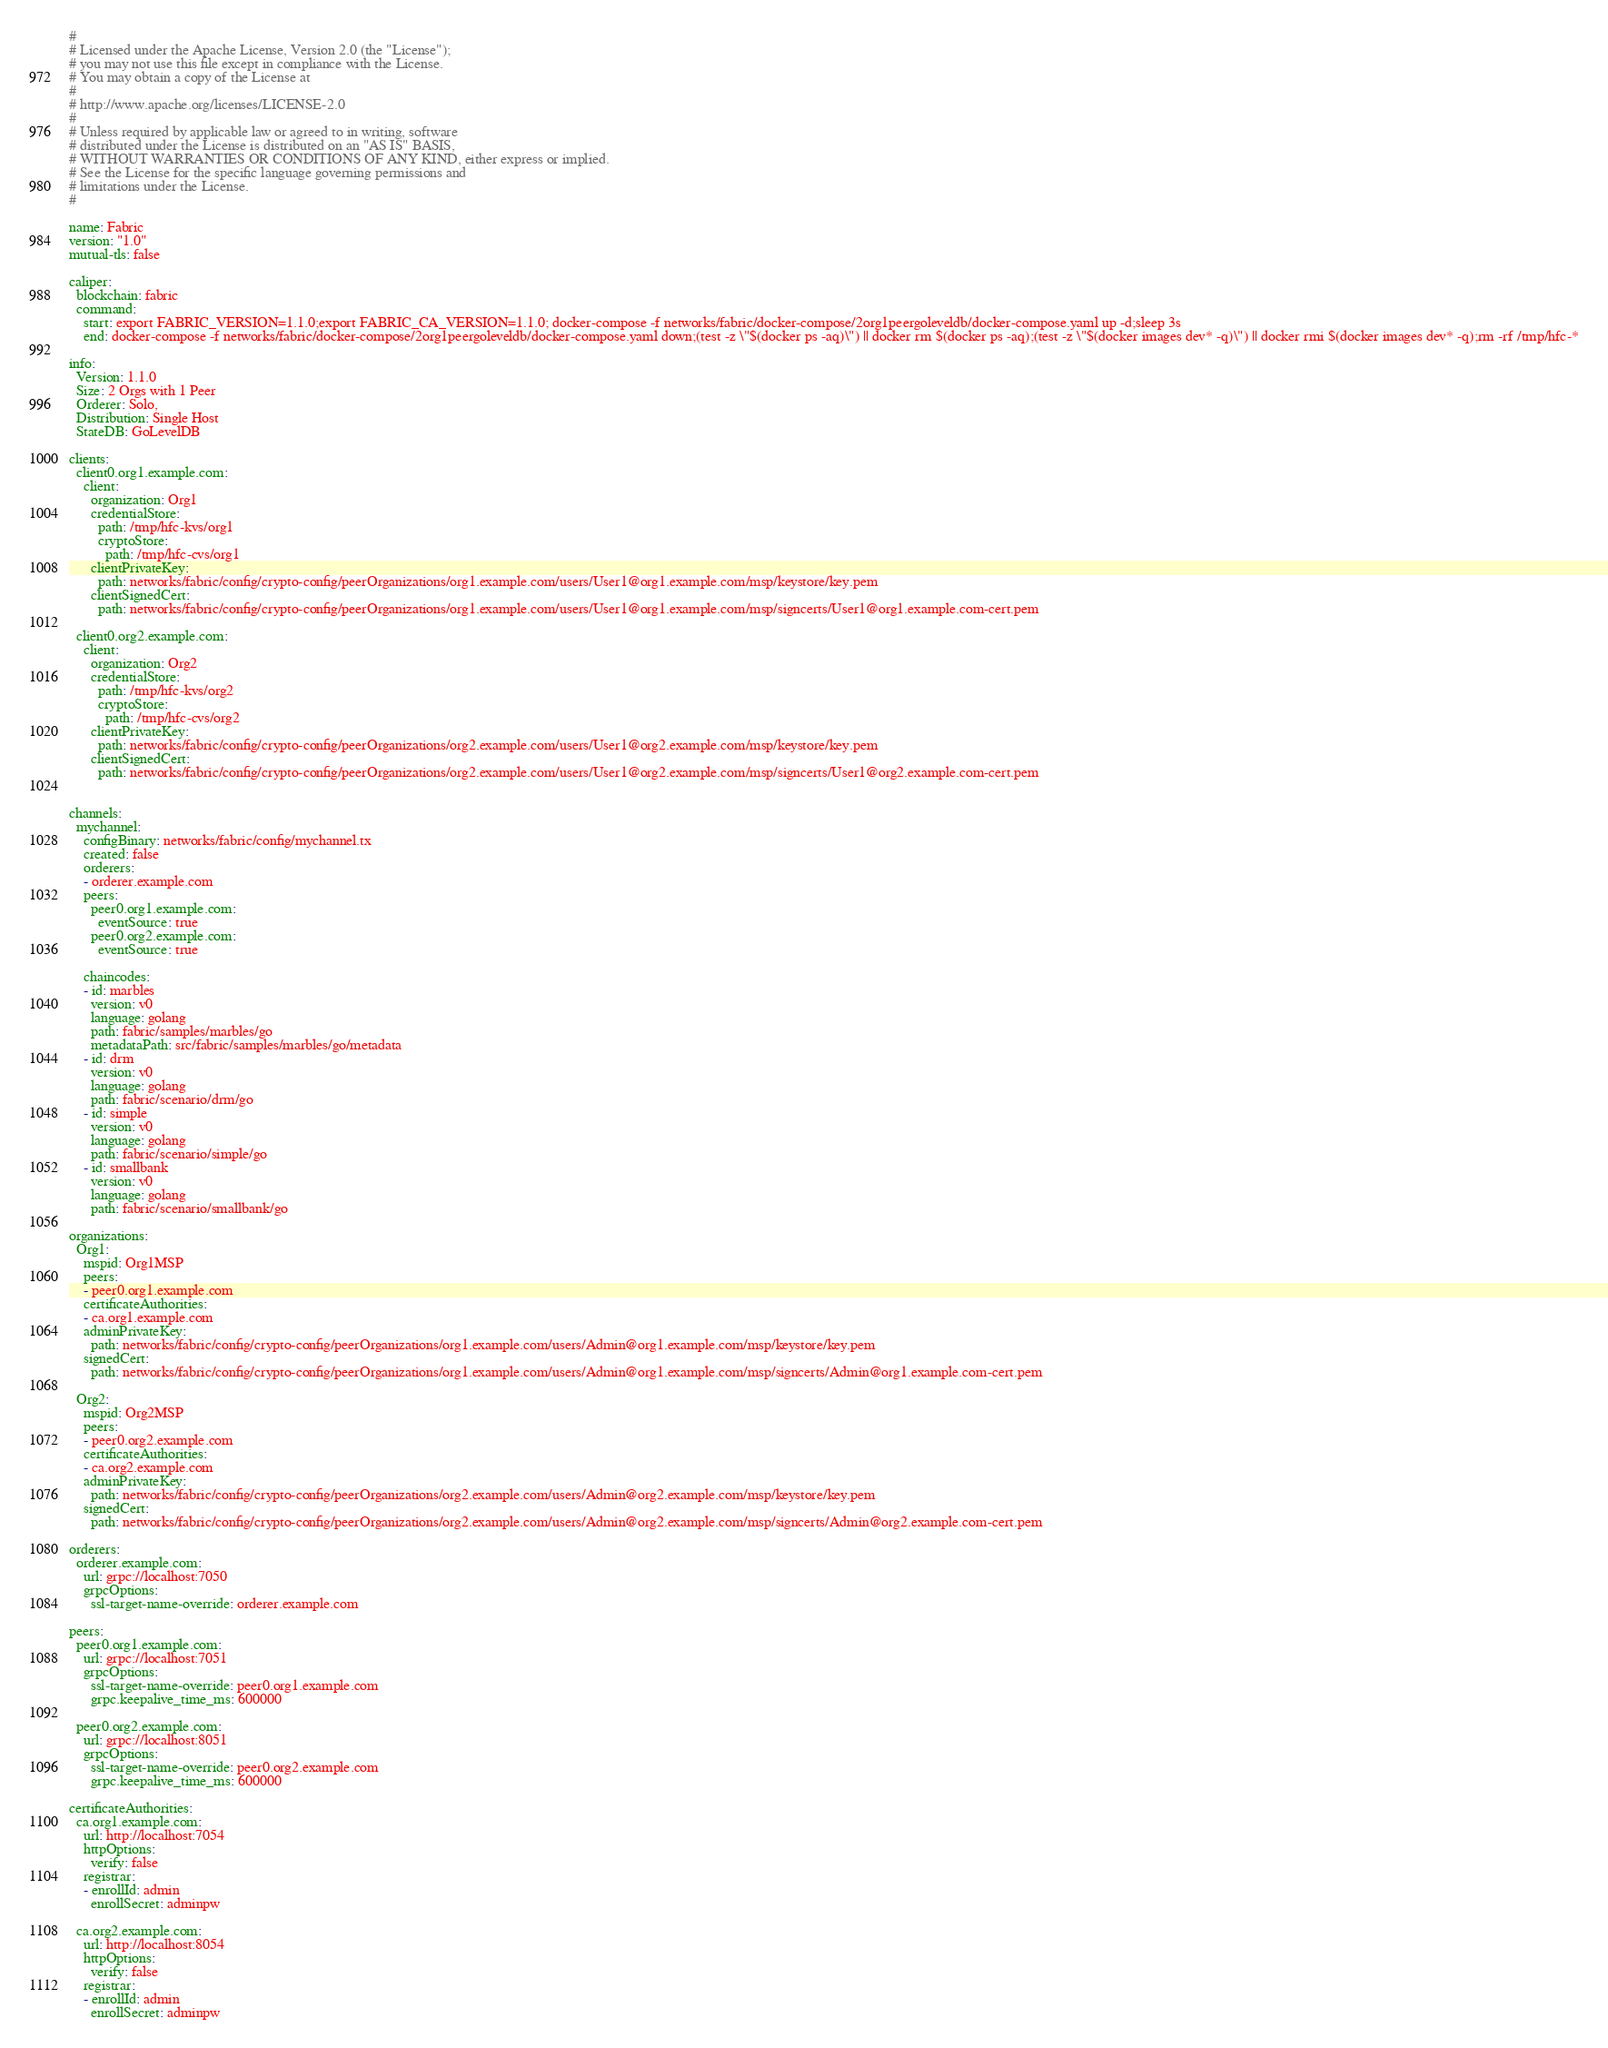<code> <loc_0><loc_0><loc_500><loc_500><_YAML_>#
# Licensed under the Apache License, Version 2.0 (the "License");
# you may not use this file except in compliance with the License.
# You may obtain a copy of the License at
#
# http://www.apache.org/licenses/LICENSE-2.0
#
# Unless required by applicable law or agreed to in writing, software
# distributed under the License is distributed on an "AS IS" BASIS,
# WITHOUT WARRANTIES OR CONDITIONS OF ANY KIND, either express or implied.
# See the License for the specific language governing permissions and
# limitations under the License.
# 

name: Fabric
version: "1.0"
mutual-tls: false

caliper:
  blockchain: fabric
  command:
    start: export FABRIC_VERSION=1.1.0;export FABRIC_CA_VERSION=1.1.0; docker-compose -f networks/fabric/docker-compose/2org1peergoleveldb/docker-compose.yaml up -d;sleep 3s
    end: docker-compose -f networks/fabric/docker-compose/2org1peergoleveldb/docker-compose.yaml down;(test -z \"$(docker ps -aq)\") || docker rm $(docker ps -aq);(test -z \"$(docker images dev* -q)\") || docker rmi $(docker images dev* -q);rm -rf /tmp/hfc-*

info:
  Version: 1.1.0
  Size: 2 Orgs with 1 Peer
  Orderer: Solo,
  Distribution: Single Host
  StateDB: GoLevelDB

clients:
  client0.org1.example.com:
    client:
      organization: Org1
      credentialStore:
        path: /tmp/hfc-kvs/org1
        cryptoStore:
          path: /tmp/hfc-cvs/org1
      clientPrivateKey:
        path: networks/fabric/config/crypto-config/peerOrganizations/org1.example.com/users/User1@org1.example.com/msp/keystore/key.pem
      clientSignedCert:
        path: networks/fabric/config/crypto-config/peerOrganizations/org1.example.com/users/User1@org1.example.com/msp/signcerts/User1@org1.example.com-cert.pem

  client0.org2.example.com:
    client:
      organization: Org2
      credentialStore:
        path: /tmp/hfc-kvs/org2
        cryptoStore:
          path: /tmp/hfc-cvs/org2
      clientPrivateKey:
        path: networks/fabric/config/crypto-config/peerOrganizations/org2.example.com/users/User1@org2.example.com/msp/keystore/key.pem
      clientSignedCert:
        path: networks/fabric/config/crypto-config/peerOrganizations/org2.example.com/users/User1@org2.example.com/msp/signcerts/User1@org2.example.com-cert.pem


channels:
  mychannel:
    configBinary: networks/fabric/config/mychannel.tx
    created: false
    orderers:
    - orderer.example.com
    peers:
      peer0.org1.example.com:
        eventSource: true
      peer0.org2.example.com:
        eventSource: true

    chaincodes:
    - id: marbles
      version: v0
      language: golang
      path: fabric/samples/marbles/go
      metadataPath: src/fabric/samples/marbles/go/metadata
    - id: drm
      version: v0
      language: golang
      path: fabric/scenario/drm/go
    - id: simple
      version: v0
      language: golang
      path: fabric/scenario/simple/go
    - id: smallbank
      version: v0
      language: golang
      path: fabric/scenario/smallbank/go

organizations:
  Org1:
    mspid: Org1MSP
    peers:
    - peer0.org1.example.com
    certificateAuthorities:
    - ca.org1.example.com
    adminPrivateKey:
      path: networks/fabric/config/crypto-config/peerOrganizations/org1.example.com/users/Admin@org1.example.com/msp/keystore/key.pem
    signedCert:
      path: networks/fabric/config/crypto-config/peerOrganizations/org1.example.com/users/Admin@org1.example.com/msp/signcerts/Admin@org1.example.com-cert.pem

  Org2:
    mspid: Org2MSP
    peers:
    - peer0.org2.example.com
    certificateAuthorities:
    - ca.org2.example.com
    adminPrivateKey:
      path: networks/fabric/config/crypto-config/peerOrganizations/org2.example.com/users/Admin@org2.example.com/msp/keystore/key.pem
    signedCert:
      path: networks/fabric/config/crypto-config/peerOrganizations/org2.example.com/users/Admin@org2.example.com/msp/signcerts/Admin@org2.example.com-cert.pem

orderers:
  orderer.example.com:
    url: grpc://localhost:7050
    grpcOptions:
      ssl-target-name-override: orderer.example.com

peers:
  peer0.org1.example.com:
    url: grpc://localhost:7051
    grpcOptions:
      ssl-target-name-override: peer0.org1.example.com
      grpc.keepalive_time_ms: 600000

  peer0.org2.example.com:
    url: grpc://localhost:8051
    grpcOptions:
      ssl-target-name-override: peer0.org2.example.com
      grpc.keepalive_time_ms: 600000

certificateAuthorities:
  ca.org1.example.com:
    url: http://localhost:7054
    httpOptions:
      verify: false
    registrar:
    - enrollId: admin
      enrollSecret: adminpw

  ca.org2.example.com:
    url: http://localhost:8054
    httpOptions:
      verify: false
    registrar:
    - enrollId: admin
      enrollSecret: adminpw
</code> 